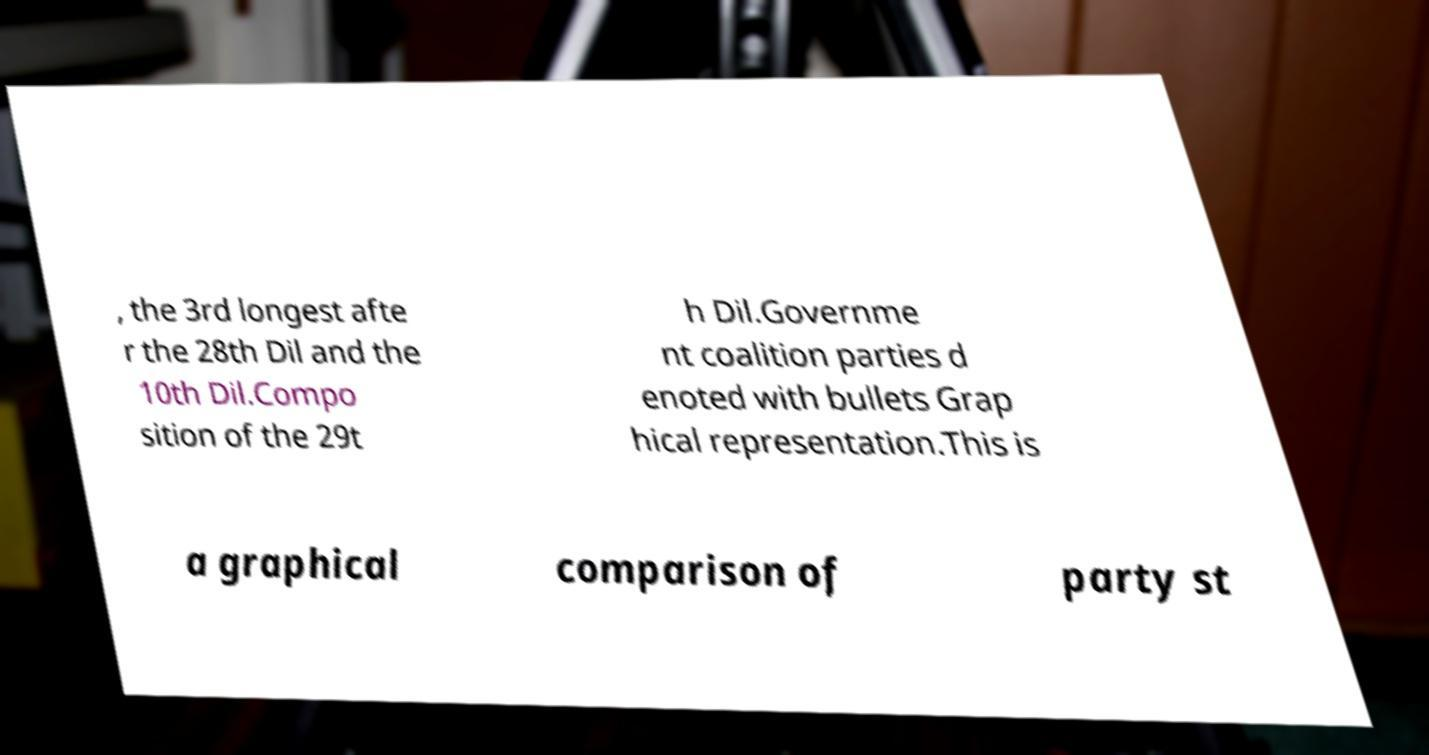Can you read and provide the text displayed in the image?This photo seems to have some interesting text. Can you extract and type it out for me? , the 3rd longest afte r the 28th Dil and the 10th Dil.Compo sition of the 29t h Dil.Governme nt coalition parties d enoted with bullets Grap hical representation.This is a graphical comparison of party st 